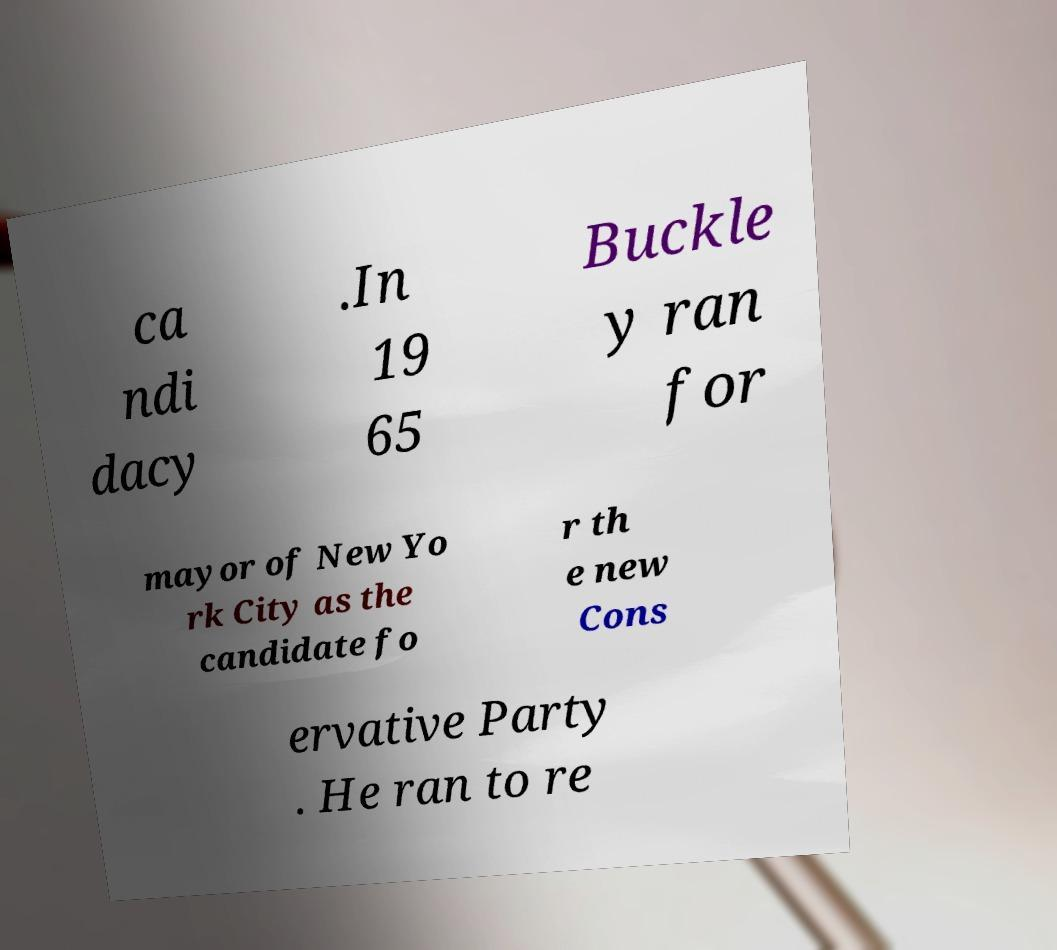Could you assist in decoding the text presented in this image and type it out clearly? ca ndi dacy .In 19 65 Buckle y ran for mayor of New Yo rk City as the candidate fo r th e new Cons ervative Party . He ran to re 